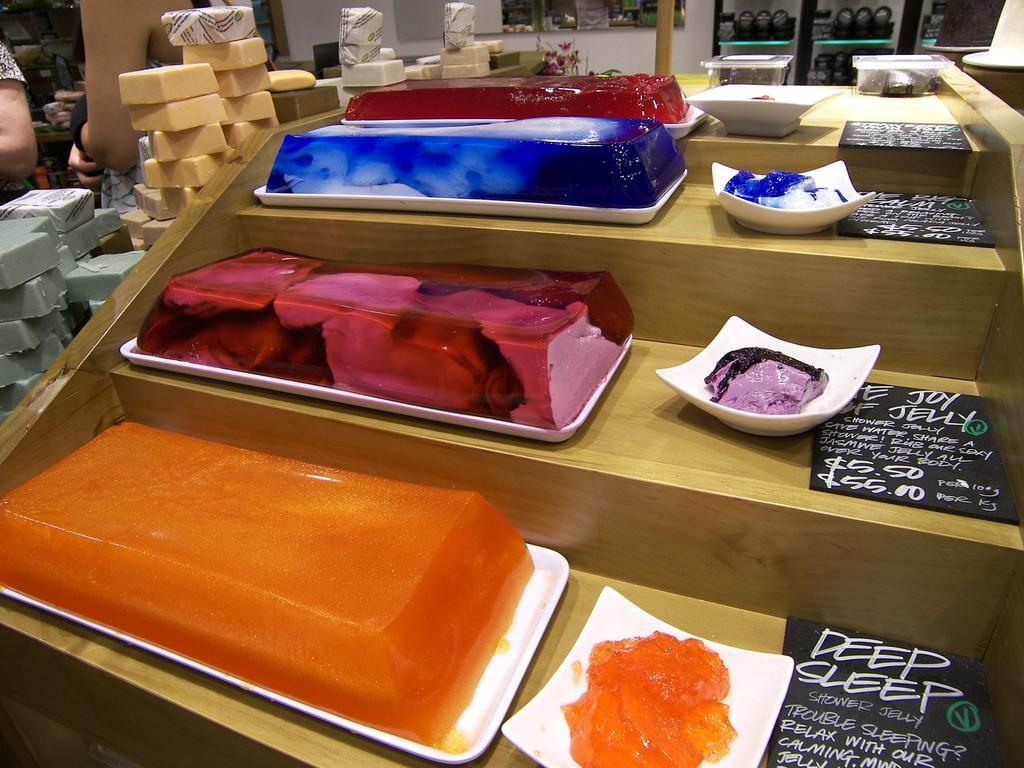Could you give a brief overview of what you see in this image? This image consists of cakes and jellies kept on the plates. To the left, there are candies. To the right, there are boards kept on the desk made up of wood. 